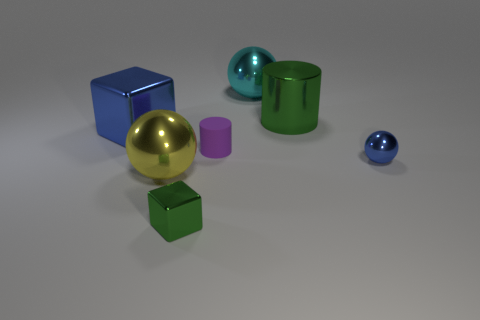What is the ball that is in front of the tiny sphere made of?
Give a very brief answer. Metal. Is there anything else that is the same color as the tiny cube?
Provide a succinct answer. Yes. What is the size of the cyan ball that is made of the same material as the blue block?
Ensure brevity in your answer.  Large. How many big things are either blue things or cyan matte balls?
Your answer should be compact. 1. What is the size of the green thing left of the cylinder that is in front of the green thing behind the purple cylinder?
Ensure brevity in your answer.  Small. How many purple metal cylinders have the same size as the blue shiny cube?
Offer a very short reply. 0. How many objects are large yellow spheres or green things that are on the right side of the large blue shiny cube?
Your response must be concise. 3. What shape is the big blue thing?
Give a very brief answer. Cube. Does the metallic cylinder have the same color as the tiny shiny block?
Ensure brevity in your answer.  Yes. There is a shiny cylinder that is the same size as the cyan object; what is its color?
Ensure brevity in your answer.  Green. 